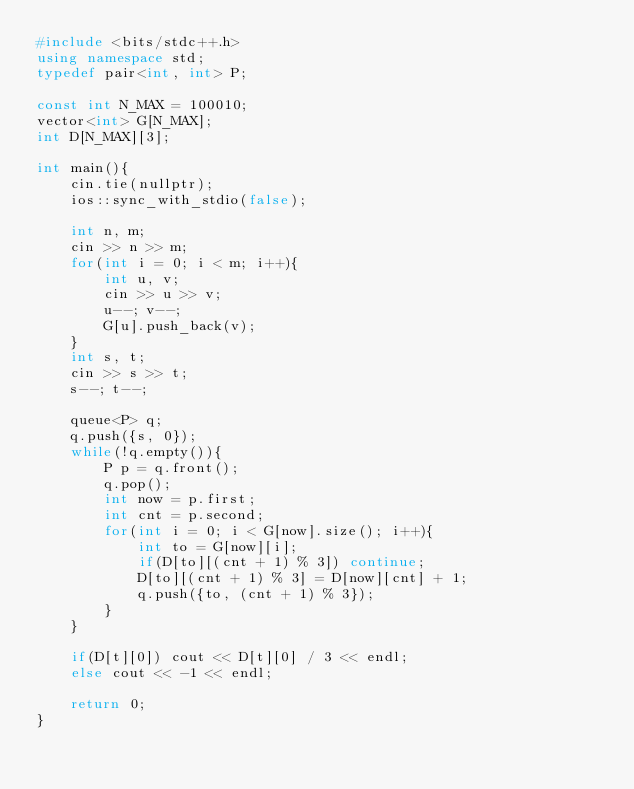Convert code to text. <code><loc_0><loc_0><loc_500><loc_500><_C++_>#include <bits/stdc++.h>
using namespace std;
typedef pair<int, int> P;

const int N_MAX = 100010;
vector<int> G[N_MAX];
int D[N_MAX][3];

int main(){
    cin.tie(nullptr);
    ios::sync_with_stdio(false);

    int n, m;
    cin >> n >> m;
    for(int i = 0; i < m; i++){
        int u, v;
        cin >> u >> v;
        u--; v--;
        G[u].push_back(v);
    }
    int s, t;
    cin >> s >> t;
    s--; t--;

    queue<P> q;
    q.push({s, 0});
    while(!q.empty()){
        P p = q.front();
        q.pop();
        int now = p.first;
        int cnt = p.second;
        for(int i = 0; i < G[now].size(); i++){
            int to = G[now][i];
            if(D[to][(cnt + 1) % 3]) continue;
            D[to][(cnt + 1) % 3] = D[now][cnt] + 1;
            q.push({to, (cnt + 1) % 3});
        }
    }

    if(D[t][0]) cout << D[t][0] / 3 << endl;
    else cout << -1 << endl;

    return 0;
}</code> 